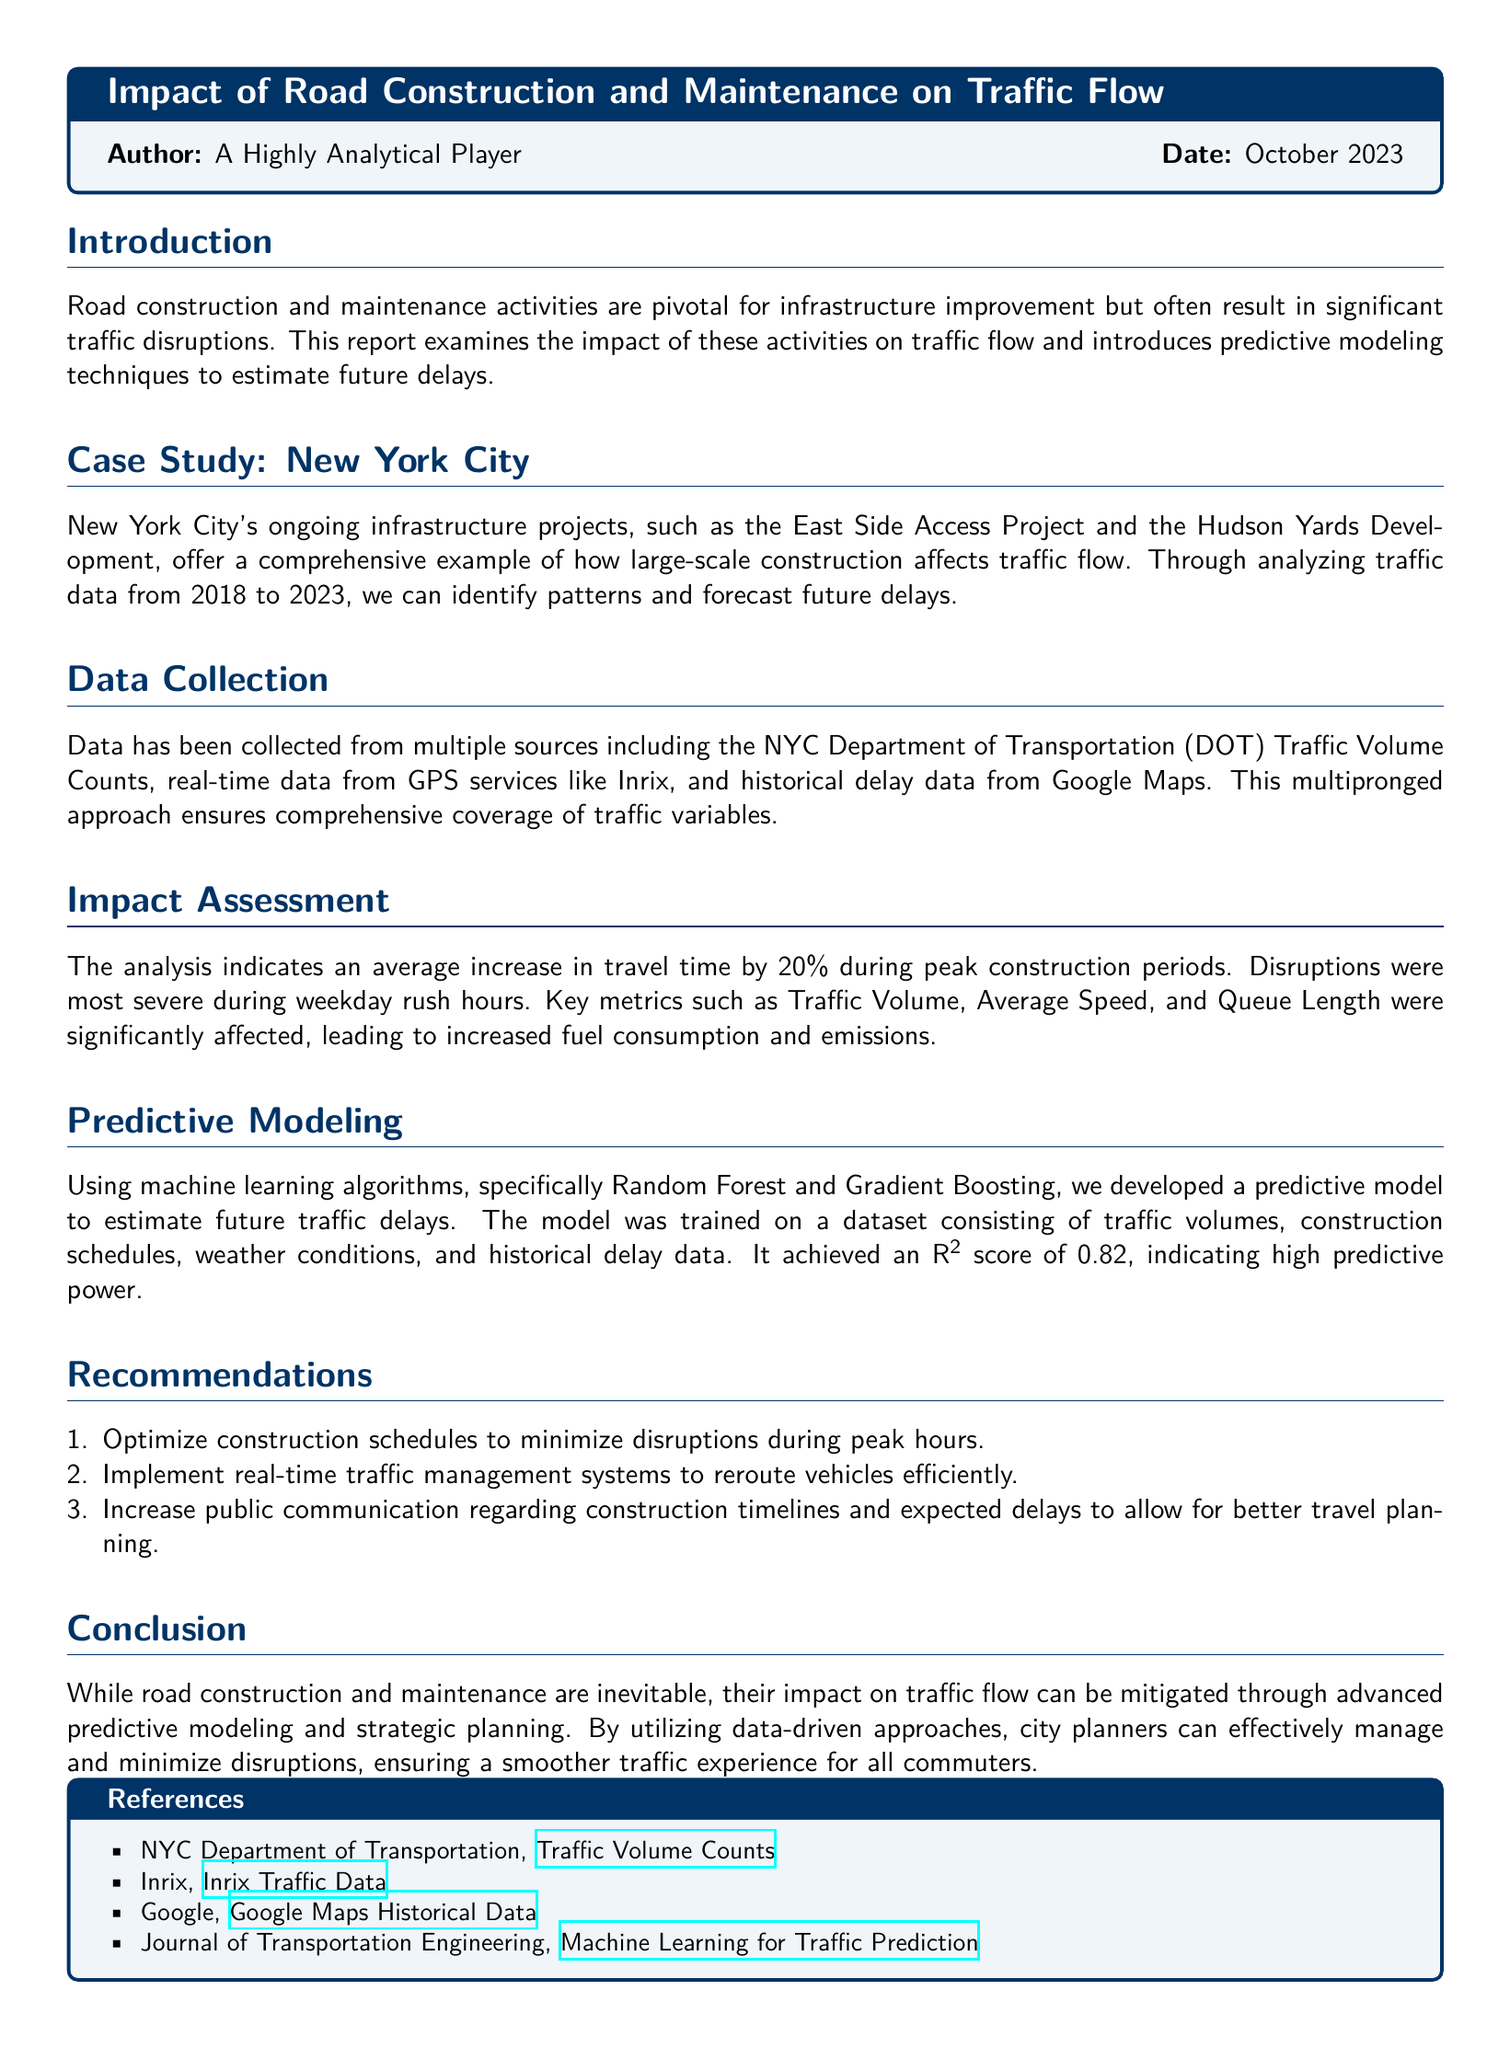What is the average increase in travel time during peak construction periods? The document states that there is an average increase in travel time by 20% during peak construction periods.
Answer: 20% Which city's traffic flow is analyzed in this report? The report focuses on the traffic flow in New York City.
Answer: New York City What two machine learning algorithms were used in the predictive modeling? The document specifies that Random Forest and Gradient Boosting were used for predictive modeling.
Answer: Random Forest and Gradient Boosting What R-squared score did the predictive model achieve? The document mentions that the predictive model achieved an R² score of 0.82.
Answer: 0.82 What is one recommendation for minimizing traffic disruptions? The document suggests optimizing construction schedules to minimize disruptions during peak hours as one of the recommendations.
Answer: Optimize construction schedules What year is the data for the case study collected until? The report highlights that traffic data was collected from 2018 to 2023.
Answer: 2023 What does the analysis indicate regarding weekday rush hours? The document notes that disruptions were most severe during weekday rush hours.
Answer: Most severe What was the purpose of collecting multipronged traffic data sources? The document explains that this approach ensures comprehensive coverage of traffic variables.
Answer: Comprehensive coverage Which source provides traffic volume counts as mentioned in the references? The NYC Department of Transportation provides traffic volume counts according to the references section.
Answer: NYC Department of Transportation 